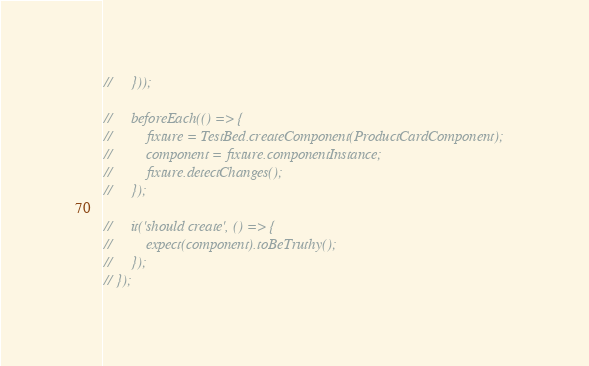<code> <loc_0><loc_0><loc_500><loc_500><_TypeScript_>//     }));

//     beforeEach(() => {
//         fixture = TestBed.createComponent(ProductCardComponent);
//         component = fixture.componentInstance;
//         fixture.detectChanges();
//     });

//     it('should create', () => {
//         expect(component).toBeTruthy();
//     });
// });
</code> 